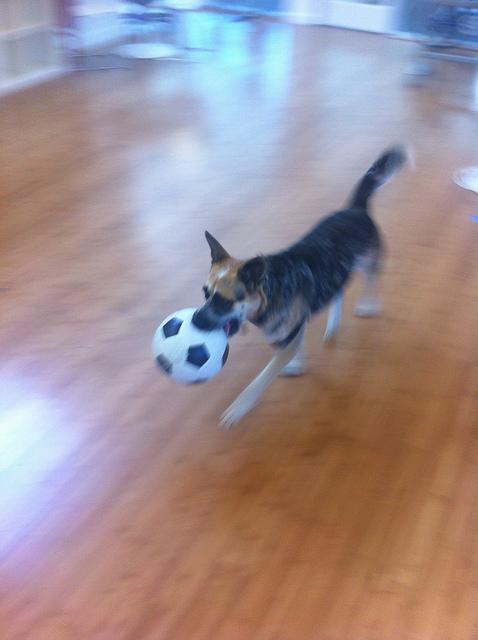What kind of ball is it?
Write a very short answer. Soccer. Is this floor carpeted?
Keep it brief. No. What does the dog have in its mouth?
Give a very brief answer. Ball. 